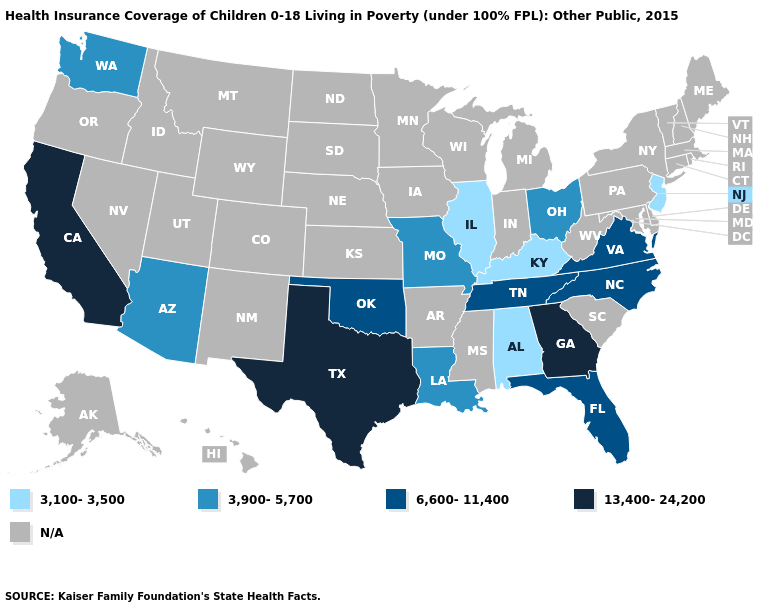Name the states that have a value in the range 3,100-3,500?
Short answer required. Alabama, Illinois, Kentucky, New Jersey. Name the states that have a value in the range 13,400-24,200?
Concise answer only. California, Georgia, Texas. Does California have the highest value in the USA?
Answer briefly. Yes. Name the states that have a value in the range 13,400-24,200?
Short answer required. California, Georgia, Texas. What is the lowest value in the USA?
Quick response, please. 3,100-3,500. What is the value of Pennsylvania?
Quick response, please. N/A. Name the states that have a value in the range 13,400-24,200?
Keep it brief. California, Georgia, Texas. Which states hav the highest value in the West?
Keep it brief. California. Name the states that have a value in the range 3,100-3,500?
Quick response, please. Alabama, Illinois, Kentucky, New Jersey. Does Texas have the highest value in the South?
Quick response, please. Yes. What is the value of Maine?
Give a very brief answer. N/A. Name the states that have a value in the range 3,100-3,500?
Give a very brief answer. Alabama, Illinois, Kentucky, New Jersey. 